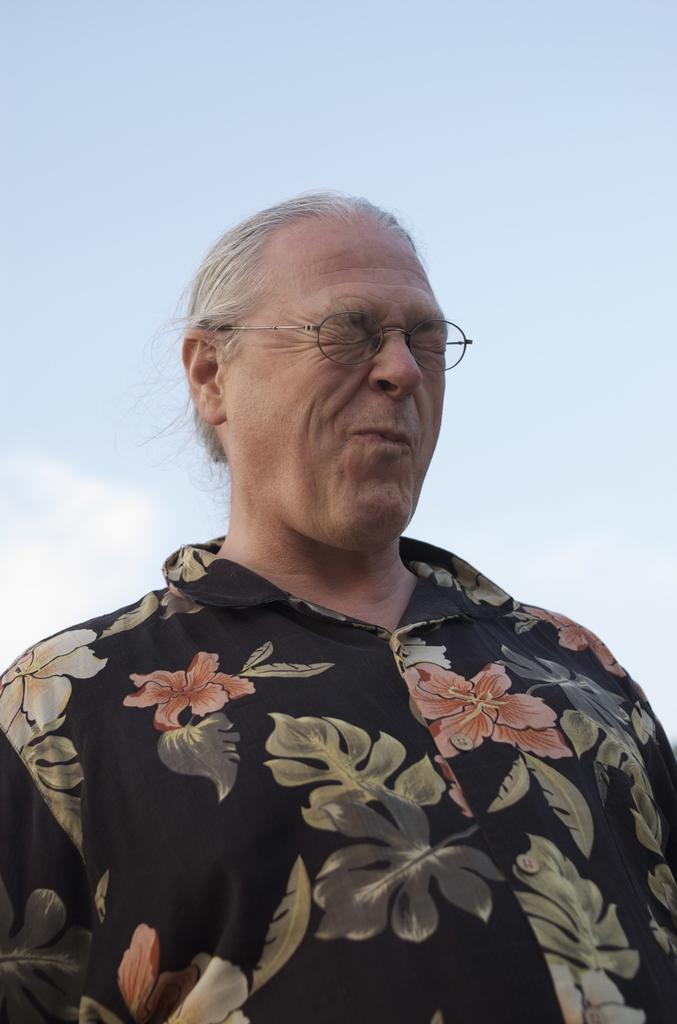What is the main subject of the image? There is a person standing in the image. What can be seen in the background of the image? The sky is visible in the background of the image. What type of news is the person reading in the image? There is no news or reading material visible in the image; it only shows a person standing and the sky in the background. 